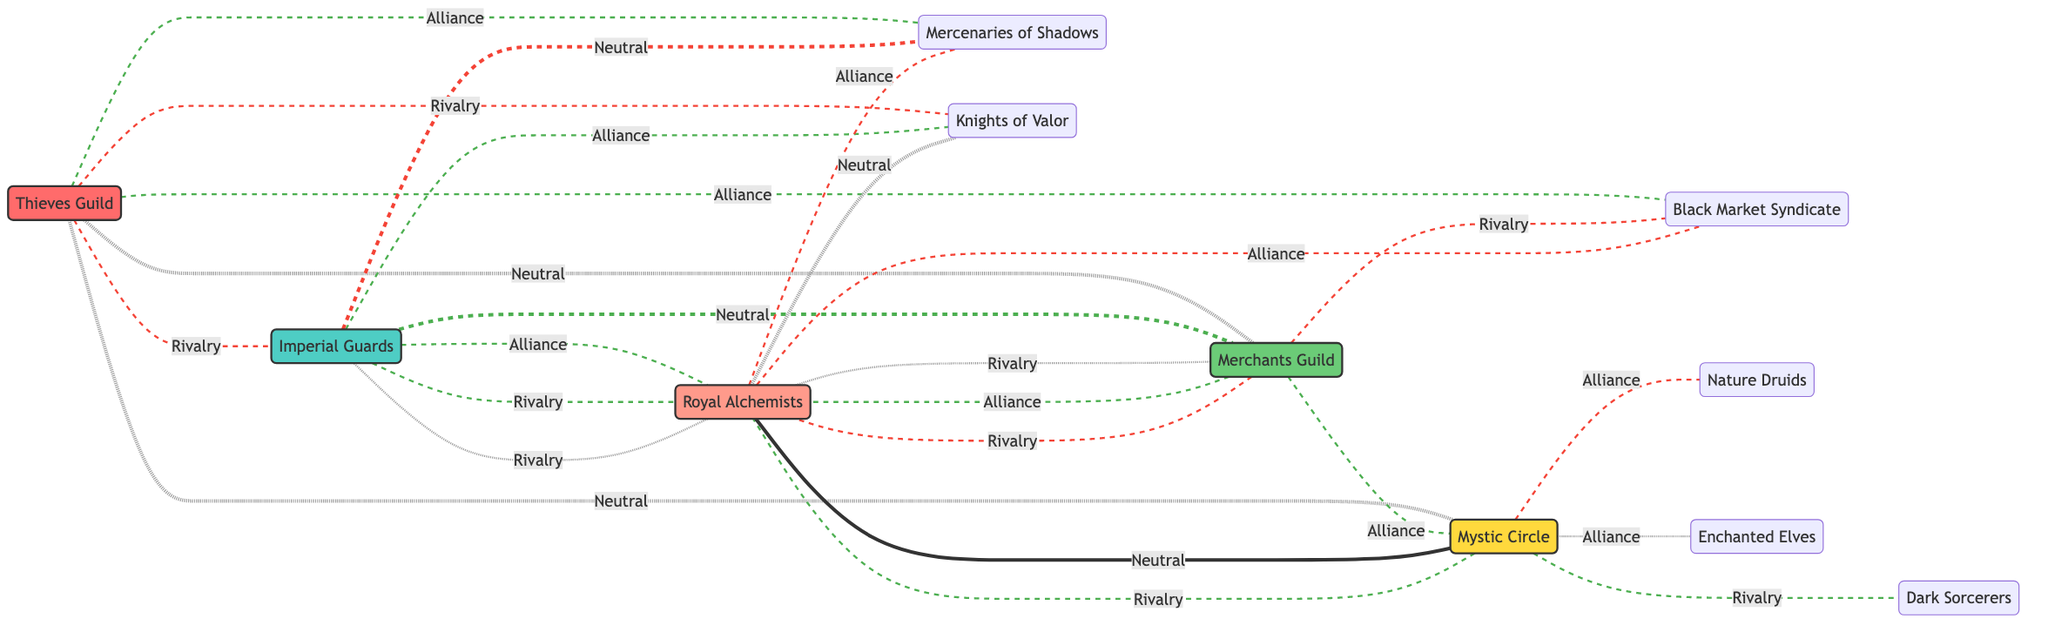What is the type of the Thieves Guild? The Thieves Guild is classified as a Criminal faction, which can be determined by looking at the label attached to the Thieves Guild node in the diagram.
Answer: Criminal How many alliances does the Imperial Guards have? The Imperial Guards have two alliances, which can be counted by examining the connections labeled as "Alliance" coming from the Imperial Guards node.
Answer: 2 Which factions are in rivalry with the Mystic Circle? The Mystic Circle has two rival factions: the Rebel Alliance and the Dark Sorcerers. This can be identified by checking the connections labeled as "Rivalry" from the Mystic Circle node.
Answer: Rebel Alliance, Dark Sorcerers What is the neutral relationship between the Rebel Alliance and the Knights of Valor? The relationship between the Rebel Alliance and the Knights of Valor is neutral, as indicated by the connection labeled as "Neutral" in the diagram.
Answer: Neutral How many factions are classified as Economic? There is only one faction classified as Economic, which is the Merchants Guild. This classification can be verified by reviewing the faction types listed in the diagram.
Answer: 1 Which faction has rivalries with both the Thieves Guild and the Merchants Guild? The Rebel Alliance has rivalries with both the Thieves Guild and the Merchants Guild, indicated by the connections from the Rebel Alliance node to both of these factions.
Answer: Rebel Alliance Identify all the magical factions that have alliances. The magical factions with alliances are the Mystic Circle (with Nature Druids and Enchanted Elves). This can be determined by checking the alliances associated with factions identified as magical in the diagram.
Answer: Mystic Circle How many total factions are represented in the diagram? The total number of factions represented in the diagram is five, which can be counted by listing each faction node shown in the diagram.
Answer: 5 Which factions are allied with both the Merchants Guild and the Imperial Guards? The Merchants Guild and the Imperial Guards are both allied with the Mystic Circle. This can be inferred by examining the alliances connected to each of these two factions and noting the common faction.
Answer: Mystic Circle 